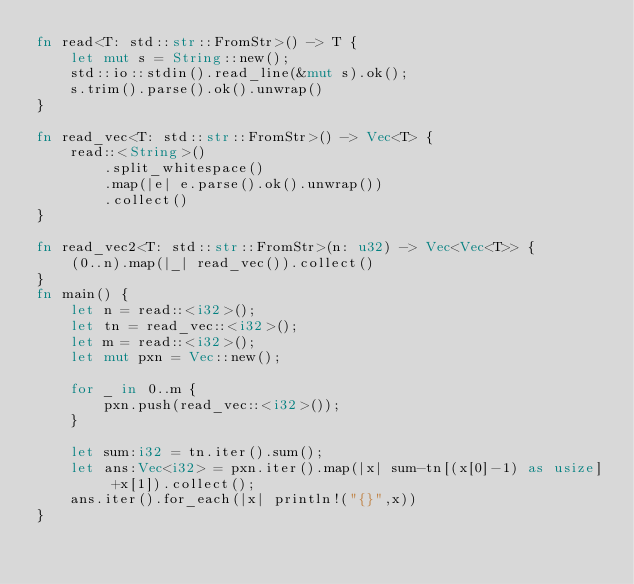<code> <loc_0><loc_0><loc_500><loc_500><_Rust_>fn read<T: std::str::FromStr>() -> T {
    let mut s = String::new();
    std::io::stdin().read_line(&mut s).ok();
    s.trim().parse().ok().unwrap()
}

fn read_vec<T: std::str::FromStr>() -> Vec<T> {
    read::<String>()
        .split_whitespace()
        .map(|e| e.parse().ok().unwrap())
        .collect()
}

fn read_vec2<T: std::str::FromStr>(n: u32) -> Vec<Vec<T>> {
    (0..n).map(|_| read_vec()).collect()
}
fn main() {
    let n = read::<i32>();
    let tn = read_vec::<i32>();
    let m = read::<i32>();
    let mut pxn = Vec::new();

    for _ in 0..m {
        pxn.push(read_vec::<i32>());
    }

    let sum:i32 = tn.iter().sum();
    let ans:Vec<i32> = pxn.iter().map(|x| sum-tn[(x[0]-1) as usize] +x[1]).collect();
    ans.iter().for_each(|x| println!("{}",x))
}</code> 